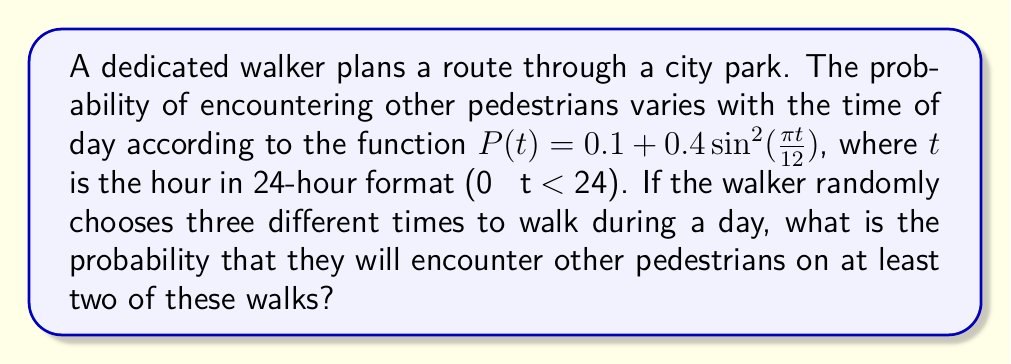Teach me how to tackle this problem. Let's approach this step-by-step:

1) First, we need to understand what the question is asking. We're looking for the probability of encountering pedestrians on at least 2 out of 3 walks.

2) This can be calculated as: P(2 encounters) + P(3 encounters)

3) To find these probabilities, we need to use the concept of expected value. The expected value of encounters for a single walk is the average of P(t) over all possible times:

   $E[P(t)] = \frac{1}{24}\int_0^{24} (0.1 + 0.4\sin^2(\frac{\pi t}{12})) dt = 0.3$

4) This means that for any randomly chosen time, the probability of encountering pedestrians is 0.3.

5) Now, we can use the binomial probability formula:

   P(X = k) = $\binom{n}{k}p^k(1-p)^{n-k}$

   where n = 3 (three walks), p = 0.3 (probability of encounter), and k is the number of successes.

6) For 2 encounters:
   P(X = 2) = $\binom{3}{2}(0.3)^2(0.7)^1 = 3 * 0.09 * 0.7 = 0.189$

7) For 3 encounters:
   P(X = 3) = $\binom{3}{3}(0.3)^3(0.7)^0 = 1 * 0.027 * 1 = 0.027$

8) The total probability is the sum of these:
   0.189 + 0.027 = 0.216
Answer: 0.216 